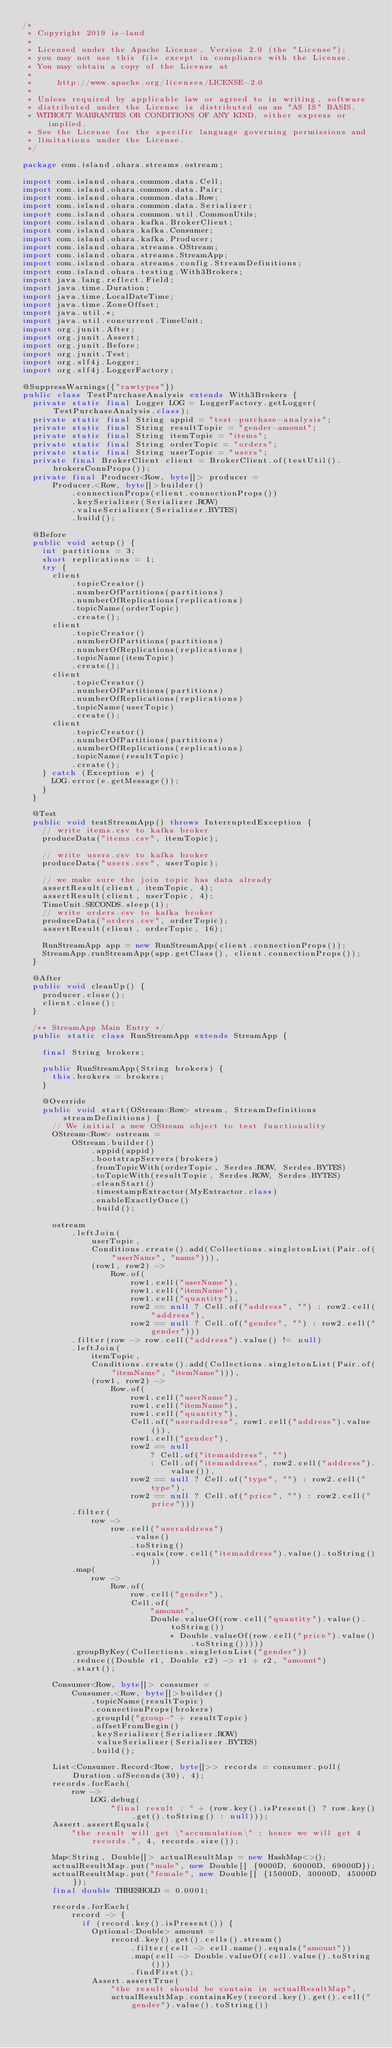<code> <loc_0><loc_0><loc_500><loc_500><_Java_>/*
 * Copyright 2019 is-land
 *
 * Licensed under the Apache License, Version 2.0 (the "License");
 * you may not use this file except in compliance with the License.
 * You may obtain a copy of the License at
 *
 *     http://www.apache.org/licenses/LICENSE-2.0
 *
 * Unless required by applicable law or agreed to in writing, software
 * distributed under the License is distributed on an "AS IS" BASIS,
 * WITHOUT WARRANTIES OR CONDITIONS OF ANY KIND, either express or implied.
 * See the License for the specific language governing permissions and
 * limitations under the License.
 */

package com.island.ohara.streams.ostream;

import com.island.ohara.common.data.Cell;
import com.island.ohara.common.data.Pair;
import com.island.ohara.common.data.Row;
import com.island.ohara.common.data.Serializer;
import com.island.ohara.common.util.CommonUtils;
import com.island.ohara.kafka.BrokerClient;
import com.island.ohara.kafka.Consumer;
import com.island.ohara.kafka.Producer;
import com.island.ohara.streams.OStream;
import com.island.ohara.streams.StreamApp;
import com.island.ohara.streams.config.StreamDefinitions;
import com.island.ohara.testing.With3Brokers;
import java.lang.reflect.Field;
import java.time.Duration;
import java.time.LocalDateTime;
import java.time.ZoneOffset;
import java.util.*;
import java.util.concurrent.TimeUnit;
import org.junit.After;
import org.junit.Assert;
import org.junit.Before;
import org.junit.Test;
import org.slf4j.Logger;
import org.slf4j.LoggerFactory;

@SuppressWarnings({"rawtypes"})
public class TestPurchaseAnalysis extends With3Brokers {
  private static final Logger LOG = LoggerFactory.getLogger(TestPurchaseAnalysis.class);
  private static final String appid = "test-purchase-analysis";
  private static final String resultTopic = "gender-amount";
  private static final String itemTopic = "items";
  private static final String orderTopic = "orders";
  private static final String userTopic = "users";
  private final BrokerClient client = BrokerClient.of(testUtil().brokersConnProps());
  private final Producer<Row, byte[]> producer =
      Producer.<Row, byte[]>builder()
          .connectionProps(client.connectionProps())
          .keySerializer(Serializer.ROW)
          .valueSerializer(Serializer.BYTES)
          .build();

  @Before
  public void setup() {
    int partitions = 3;
    short replications = 1;
    try {
      client
          .topicCreator()
          .numberOfPartitions(partitions)
          .numberOfReplications(replications)
          .topicName(orderTopic)
          .create();
      client
          .topicCreator()
          .numberOfPartitions(partitions)
          .numberOfReplications(replications)
          .topicName(itemTopic)
          .create();
      client
          .topicCreator()
          .numberOfPartitions(partitions)
          .numberOfReplications(replications)
          .topicName(userTopic)
          .create();
      client
          .topicCreator()
          .numberOfPartitions(partitions)
          .numberOfReplications(replications)
          .topicName(resultTopic)
          .create();
    } catch (Exception e) {
      LOG.error(e.getMessage());
    }
  }

  @Test
  public void testStreamApp() throws InterruptedException {
    // write items.csv to kafka broker
    produceData("items.csv", itemTopic);

    // write users.csv to kafka broker
    produceData("users.csv", userTopic);

    // we make sure the join topic has data already
    assertResult(client, itemTopic, 4);
    assertResult(client, userTopic, 4);
    TimeUnit.SECONDS.sleep(1);
    // write orders.csv to kafka broker
    produceData("orders.csv", orderTopic);
    assertResult(client, orderTopic, 16);

    RunStreamApp app = new RunStreamApp(client.connectionProps());
    StreamApp.runStreamApp(app.getClass(), client.connectionProps());
  }

  @After
  public void cleanUp() {
    producer.close();
    client.close();
  }

  /** StreamApp Main Entry */
  public static class RunStreamApp extends StreamApp {

    final String brokers;

    public RunStreamApp(String brokers) {
      this.brokers = brokers;
    }

    @Override
    public void start(OStream<Row> stream, StreamDefinitions streamDefinitions) {
      // We initial a new OStream object to test functionality
      OStream<Row> ostream =
          OStream.builder()
              .appid(appid)
              .bootstrapServers(brokers)
              .fromTopicWith(orderTopic, Serdes.ROW, Serdes.BYTES)
              .toTopicWith(resultTopic, Serdes.ROW, Serdes.BYTES)
              .cleanStart()
              .timestampExtractor(MyExtractor.class)
              .enableExactlyOnce()
              .build();

      ostream
          .leftJoin(
              userTopic,
              Conditions.create().add(Collections.singletonList(Pair.of("userName", "name"))),
              (row1, row2) ->
                  Row.of(
                      row1.cell("userName"),
                      row1.cell("itemName"),
                      row1.cell("quantity"),
                      row2 == null ? Cell.of("address", "") : row2.cell("address"),
                      row2 == null ? Cell.of("gender", "") : row2.cell("gender")))
          .filter(row -> row.cell("address").value() != null)
          .leftJoin(
              itemTopic,
              Conditions.create().add(Collections.singletonList(Pair.of("itemName", "itemName"))),
              (row1, row2) ->
                  Row.of(
                      row1.cell("userName"),
                      row1.cell("itemName"),
                      row1.cell("quantity"),
                      Cell.of("useraddress", row1.cell("address").value()),
                      row1.cell("gender"),
                      row2 == null
                          ? Cell.of("itemaddress", "")
                          : Cell.of("itemaddress", row2.cell("address").value()),
                      row2 == null ? Cell.of("type", "") : row2.cell("type"),
                      row2 == null ? Cell.of("price", "") : row2.cell("price")))
          .filter(
              row ->
                  row.cell("useraddress")
                      .value()
                      .toString()
                      .equals(row.cell("itemaddress").value().toString()))
          .map(
              row ->
                  Row.of(
                      row.cell("gender"),
                      Cell.of(
                          "amount",
                          Double.valueOf(row.cell("quantity").value().toString())
                              * Double.valueOf(row.cell("price").value().toString()))))
          .groupByKey(Collections.singletonList("gender"))
          .reduce((Double r1, Double r2) -> r1 + r2, "amount")
          .start();

      Consumer<Row, byte[]> consumer =
          Consumer.<Row, byte[]>builder()
              .topicName(resultTopic)
              .connectionProps(brokers)
              .groupId("group-" + resultTopic)
              .offsetFromBegin()
              .keySerializer(Serializer.ROW)
              .valueSerializer(Serializer.BYTES)
              .build();

      List<Consumer.Record<Row, byte[]>> records = consumer.poll(Duration.ofSeconds(30), 4);
      records.forEach(
          row ->
              LOG.debug(
                  "final result : " + (row.key().isPresent() ? row.key().get().toString() : null)));
      Assert.assertEquals(
          "the result will get \"accumulation\" ; hence we will get 4 records.", 4, records.size());

      Map<String, Double[]> actualResultMap = new HashMap<>();
      actualResultMap.put("male", new Double[] {9000D, 60000D, 69000D});
      actualResultMap.put("female", new Double[] {15000D, 30000D, 45000D});
      final double THRESHOLD = 0.0001;

      records.forEach(
          record -> {
            if (record.key().isPresent()) {
              Optional<Double> amount =
                  record.key().get().cells().stream()
                      .filter(cell -> cell.name().equals("amount"))
                      .map(cell -> Double.valueOf(cell.value().toString()))
                      .findFirst();
              Assert.assertTrue(
                  "the result should be contain in actualResultMap",
                  actualResultMap.containsKey(record.key().get().cell("gender").value().toString())</code> 